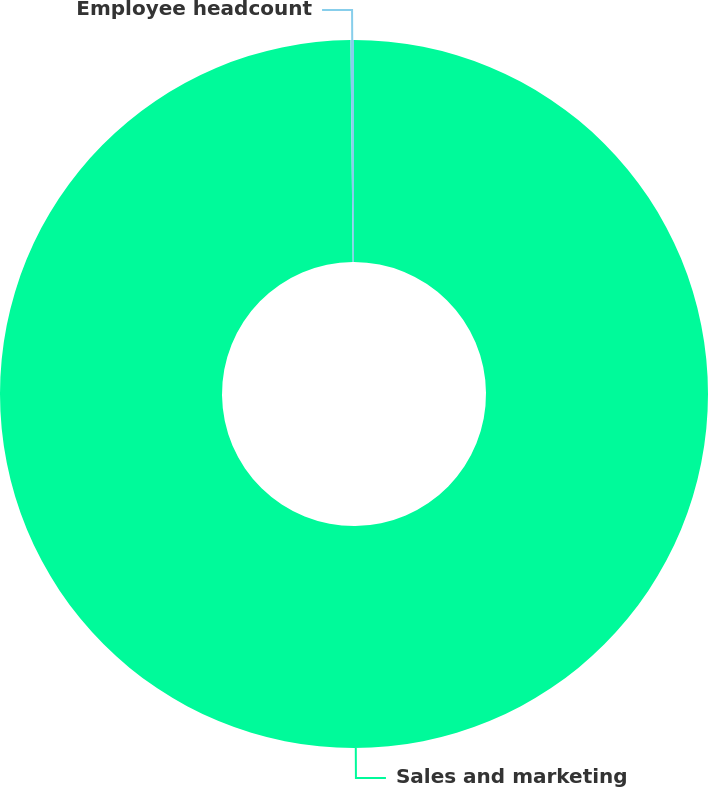Convert chart to OTSL. <chart><loc_0><loc_0><loc_500><loc_500><pie_chart><fcel>Sales and marketing<fcel>Employee headcount<nl><fcel>99.84%<fcel>0.16%<nl></chart> 